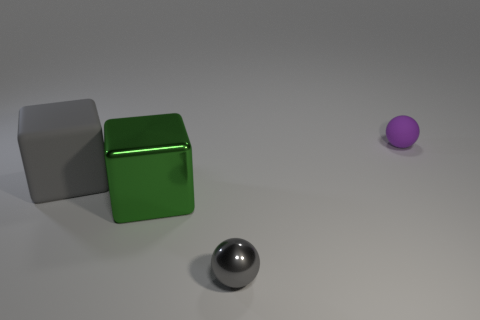Are there any gray balls of the same size as the gray rubber object?
Provide a succinct answer. No. The green metal block has what size?
Make the answer very short. Large. How many gray rubber blocks are the same size as the purple object?
Your response must be concise. 0. Are there fewer large metallic blocks right of the purple rubber thing than matte spheres that are in front of the green block?
Your answer should be compact. No. How big is the ball in front of the object that is behind the matte thing that is to the left of the tiny metallic object?
Provide a short and direct response. Small. There is a thing that is both in front of the large gray object and behind the gray ball; how big is it?
Keep it short and to the point. Large. The matte object behind the matte object that is left of the big green metal object is what shape?
Your answer should be very brief. Sphere. Are there any other things that are the same color as the shiny cube?
Keep it short and to the point. No. The object left of the big shiny block has what shape?
Your response must be concise. Cube. What is the shape of the object that is on the left side of the purple ball and on the right side of the big metal block?
Provide a succinct answer. Sphere. 